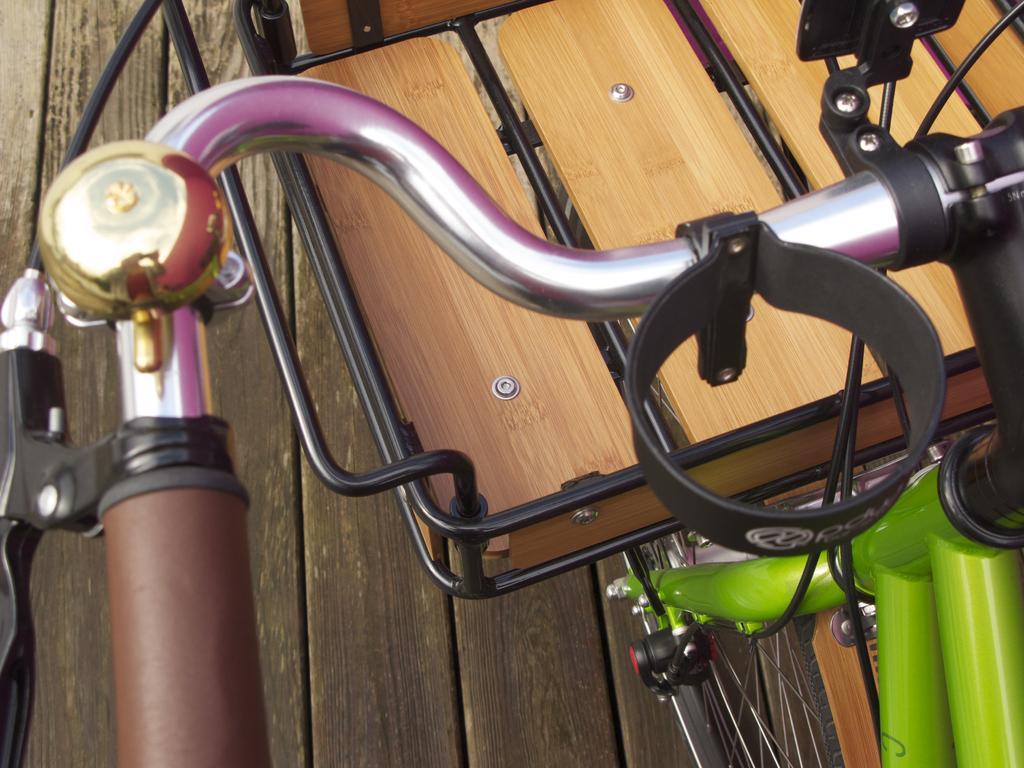In one or two sentences, can you explain what this image depicts? In this image I can see the bicycle and there is a basket in-front of the bicycle. The bicycle is on the wooden surface. 